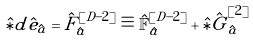<formula> <loc_0><loc_0><loc_500><loc_500>& \hat { \ast } d \hat { e } _ { \hat { a } } = \hat { F } ^ { [ D - 2 ] } _ { \hat { a } } \equiv \hat { \mathbb { F } } ^ { [ D - 2 ] } _ { \hat { a } } + \hat { \ast } \hat { \tilde { G } } ^ { [ 2 ] } _ { \hat { a } }</formula> 